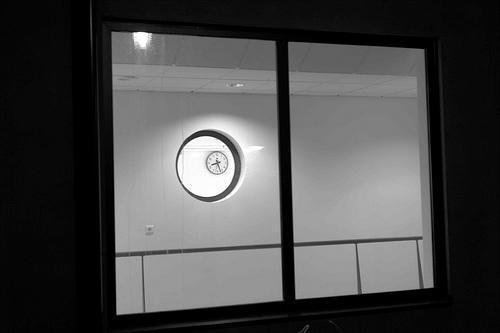How many clock on the wall?
Give a very brief answer. 1. 